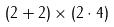<formula> <loc_0><loc_0><loc_500><loc_500>( 2 + 2 ) \times ( 2 \cdot 4 )</formula> 